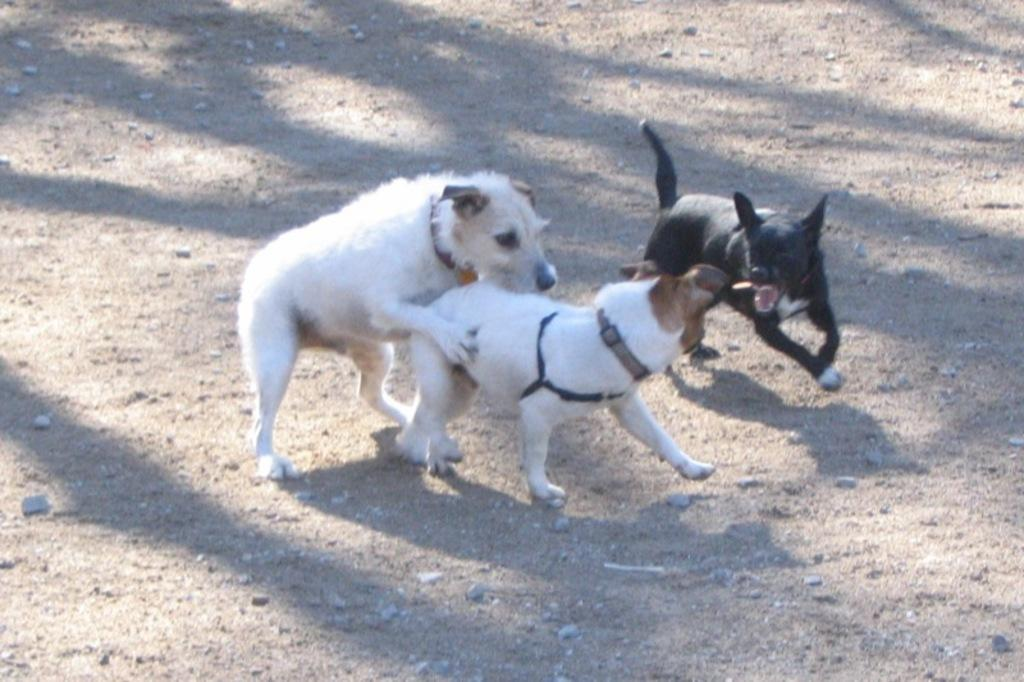What type of animals are present in the image? There is a group of dogs in the image. What is the position of the dogs in the image? The dogs are standing on the ground. What type of appliance can be seen in the image? There is no appliance present in the image; it features a group of dogs standing on the ground. Can you describe the appearance of the pig in the image? There is no pig present in the image; it only features a group of dogs. 